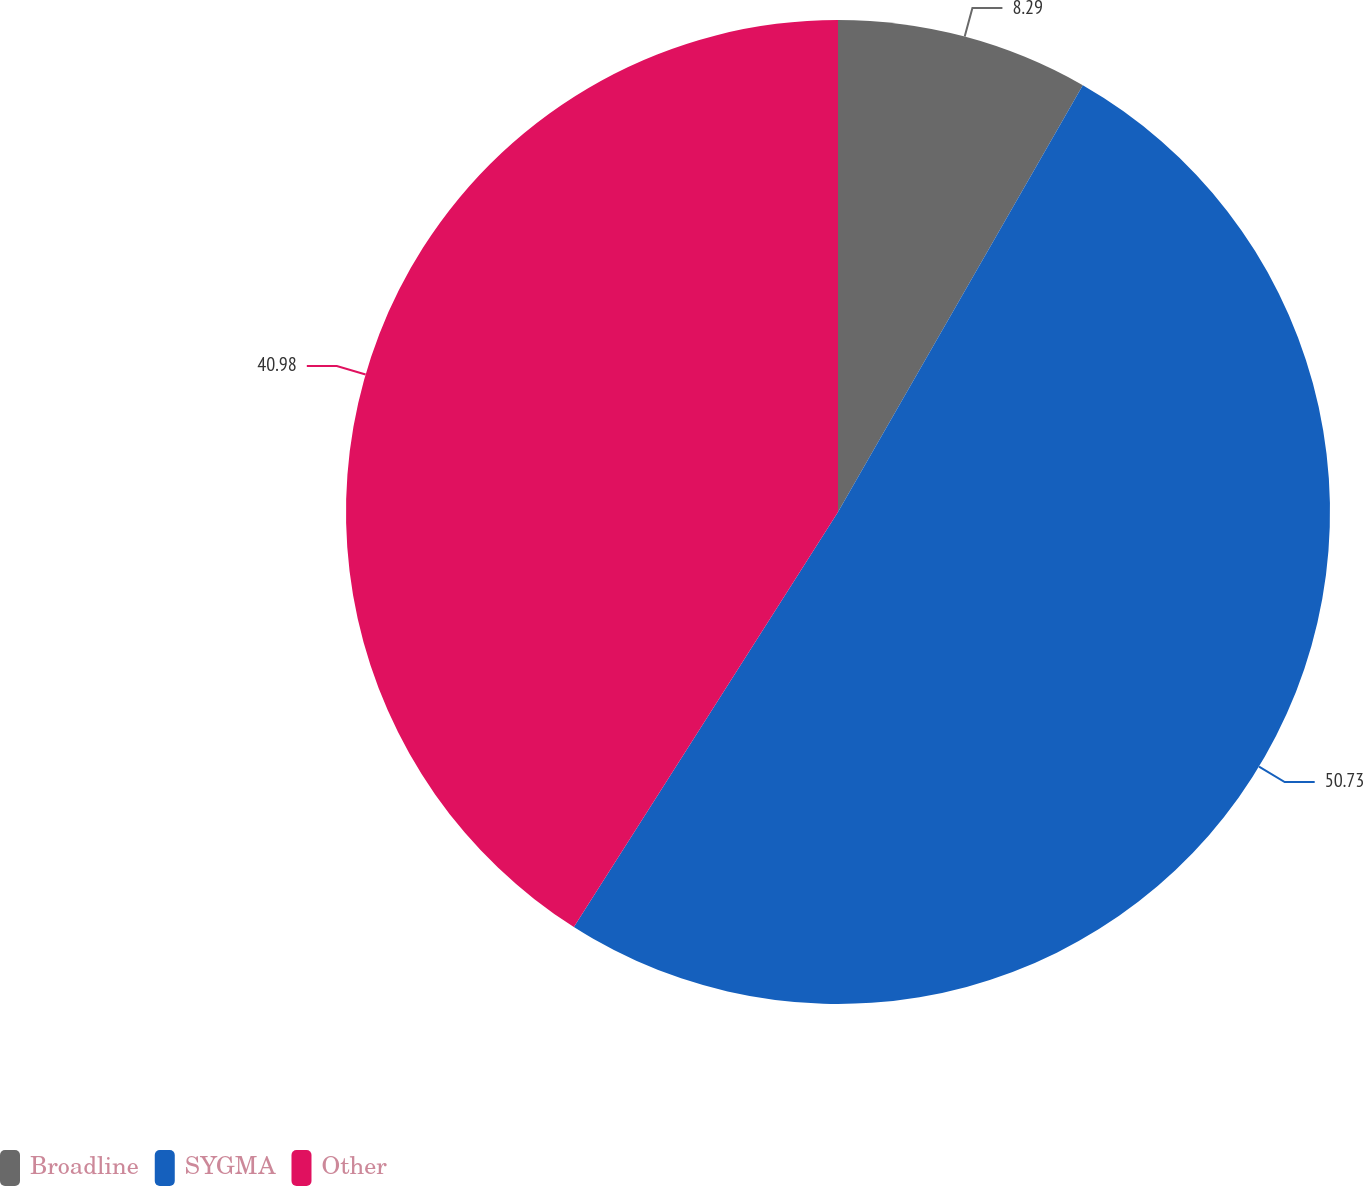Convert chart to OTSL. <chart><loc_0><loc_0><loc_500><loc_500><pie_chart><fcel>Broadline<fcel>SYGMA<fcel>Other<nl><fcel>8.29%<fcel>50.73%<fcel>40.98%<nl></chart> 